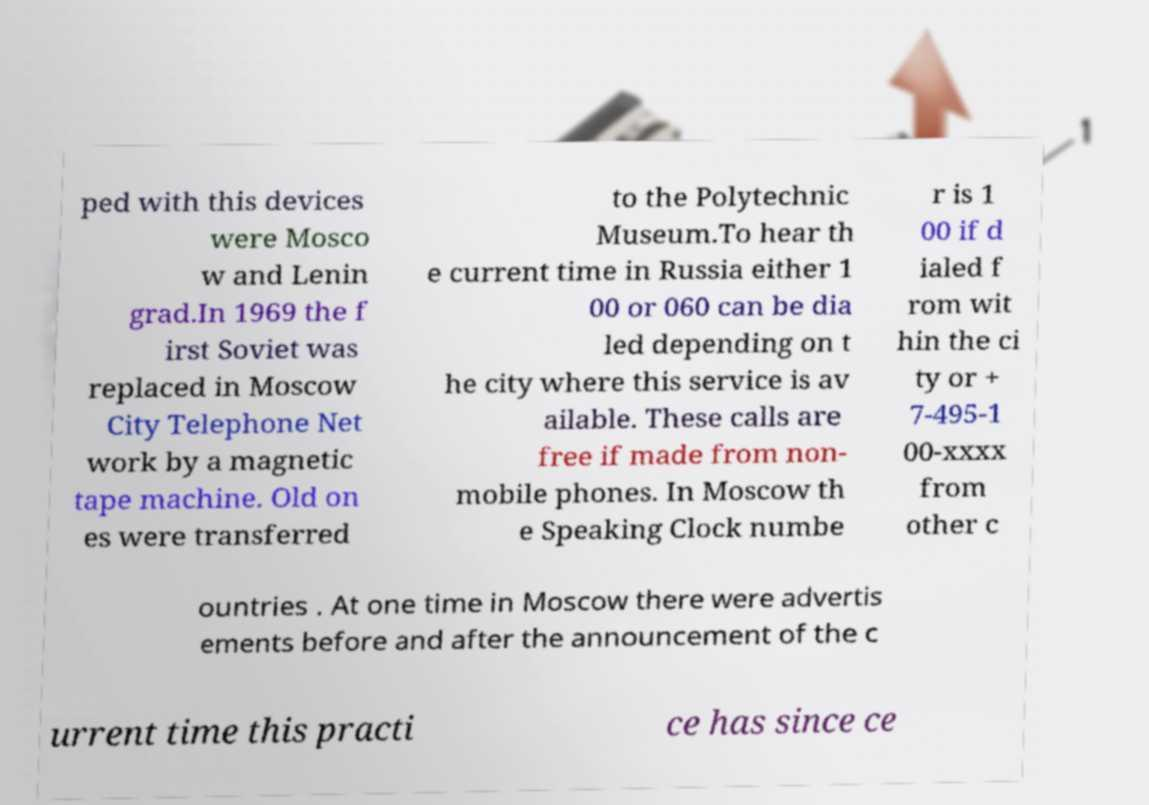Please read and relay the text visible in this image. What does it say? ped with this devices were Mosco w and Lenin grad.In 1969 the f irst Soviet was replaced in Moscow City Telephone Net work by a magnetic tape machine. Old on es were transferred to the Polytechnic Museum.To hear th e current time in Russia either 1 00 or 060 can be dia led depending on t he city where this service is av ailable. These calls are free if made from non- mobile phones. In Moscow th e Speaking Clock numbe r is 1 00 if d ialed f rom wit hin the ci ty or + 7-495-1 00-xxxx from other c ountries . At one time in Moscow there were advertis ements before and after the announcement of the c urrent time this practi ce has since ce 